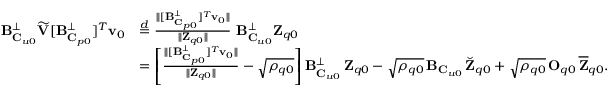Convert formula to latex. <formula><loc_0><loc_0><loc_500><loc_500>\begin{array} { r l } { B _ { C _ { u 0 } } ^ { \perp } \widetilde { V } [ B _ { C _ { p 0 } } ^ { \perp } ] ^ { T } v _ { 0 } } & { \stackrel { d } { = } \frac { \| [ B _ { C _ { p 0 } } ^ { \perp } ] ^ { T } v _ { 0 } \| } { \| Z _ { q 0 } \| } \, B _ { C _ { u 0 } } ^ { \perp } Z _ { q 0 } } \\ & { = \left [ \frac { \| [ B _ { C _ { p 0 } } ^ { \perp } ] ^ { T } v _ { 0 } \| } { \| Z _ { q 0 } \| } - \sqrt { \rho _ { q 0 } } \right ] B _ { C _ { u 0 } } ^ { \perp } \, Z _ { q 0 } - \sqrt { \rho _ { q 0 } } \, B _ { C _ { u 0 } } \, \breve { Z } _ { q 0 } + \sqrt { \rho _ { q 0 } } \, O _ { q 0 } \, \overline { Z } _ { q 0 } . } \end{array}</formula> 